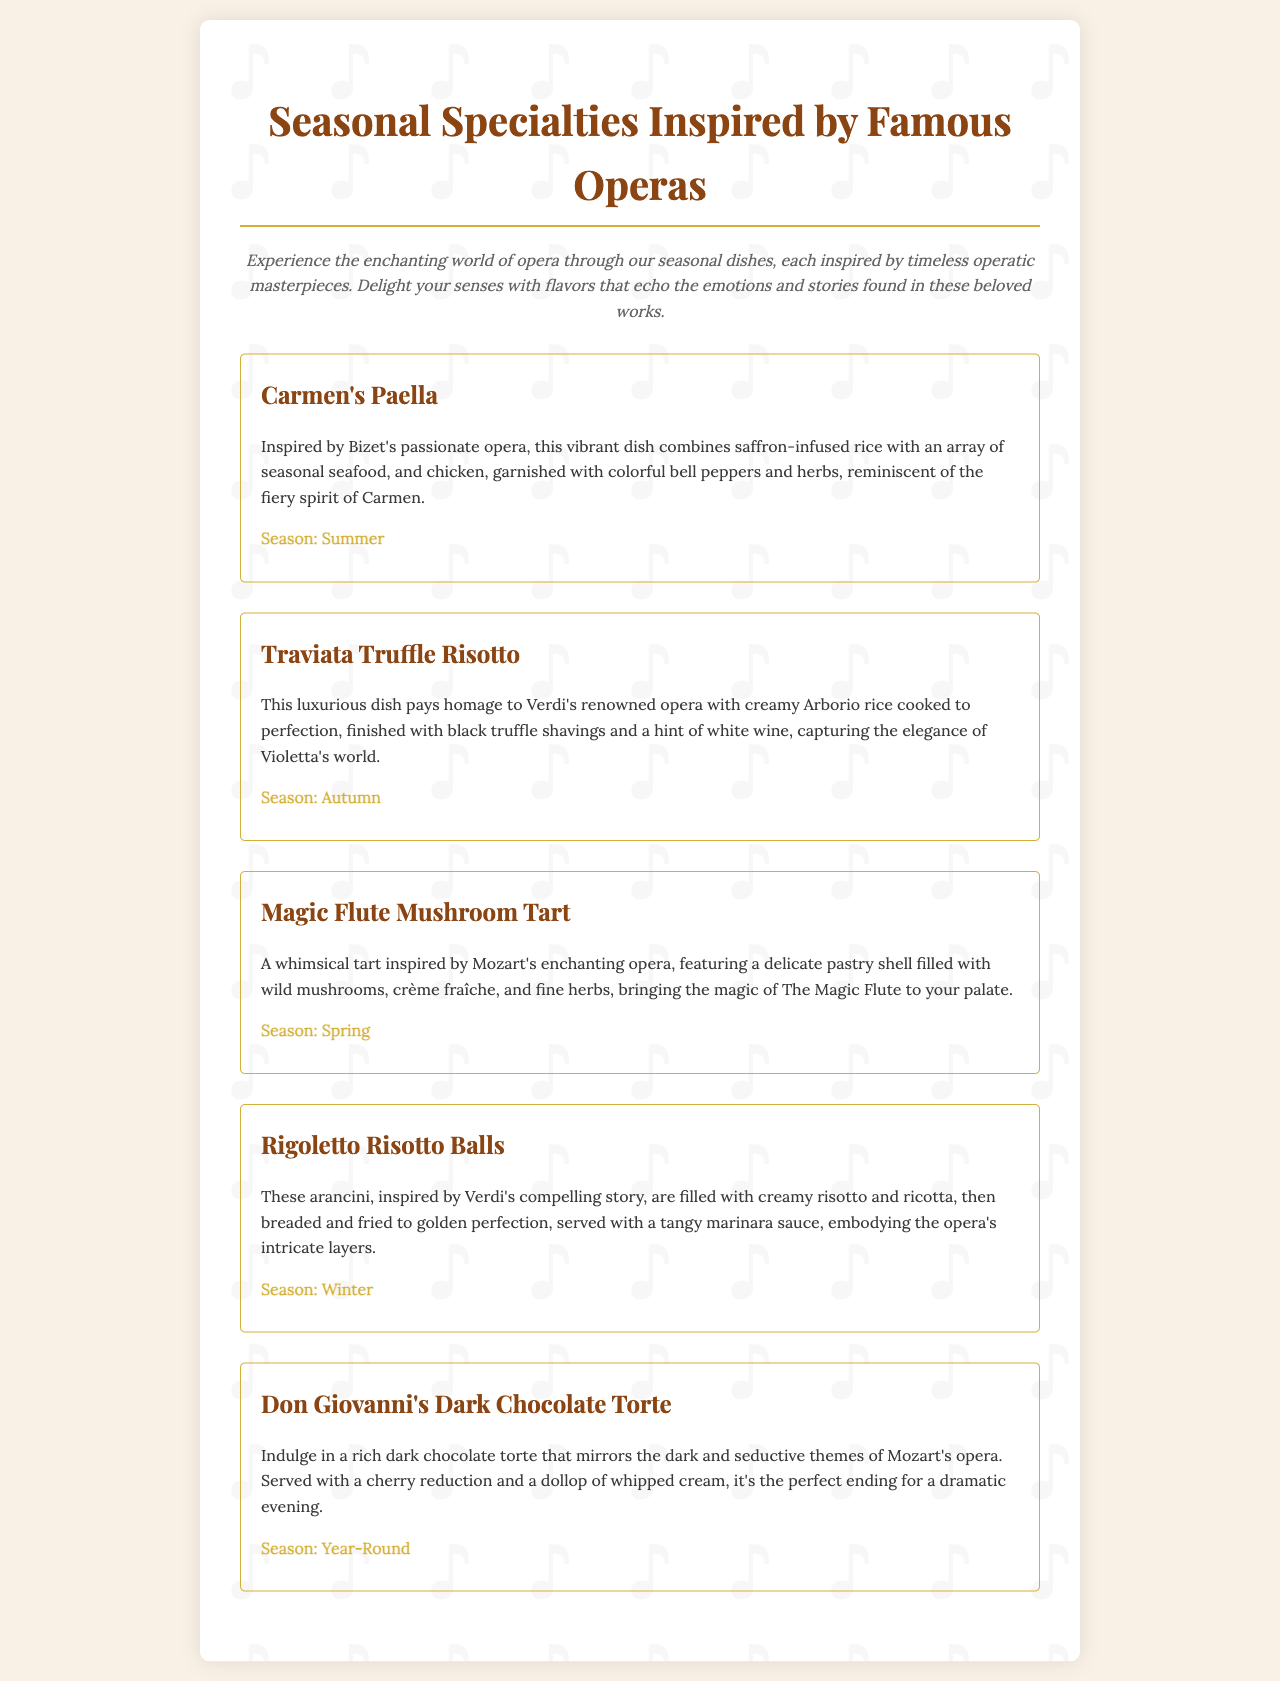What is the title of the menu? The title of the menu is presented prominently at the top of the document, indicating the theme of the offerings.
Answer: Seasonal Specialties Inspired by Famous Operas What is the first dish listed? The first dish is presented in the menu as an inviting introduction to the seasonal specialties.
Answer: Carmen's Paella What season is associated with Traviata Truffle Risotto? Each dish in the menu is accompanied by a seasonal indication, helping diners choose based on time of year.
Answer: Autumn Which chef's work inspired the dish that features a dark chocolate torte? The document highlights that many dishes are inspired by famous operas, indicating the chef's thematic creativity.
Answer: Mozart What type of dish is Magic Flute Mushroom Tart? The category of each dish can give insights into what diners might expect in terms of cuisine and presentation.
Answer: Tart Which dish is available year-round? The menu includes seasonal indications, but some dishes are available throughout the entire year.
Answer: Don Giovanni's Dark Chocolate Torte What main ingredient distinguishes Rigoletto Risotto Balls? The description of each dish often highlights key ingredients to entice diners with specific flavors.
Answer: Risotto How is Carmen’s Paella garnished? The menu provides descriptive elements that detail how dishes are presented, enhancing visual appeal.
Answer: Colorful bell peppers and herbs Which opera inspired the dish associated with spring? The thematic connections between dishes and operas can offer insights into seasonal creativity in the kitchen.
Answer: The Magic Flute 